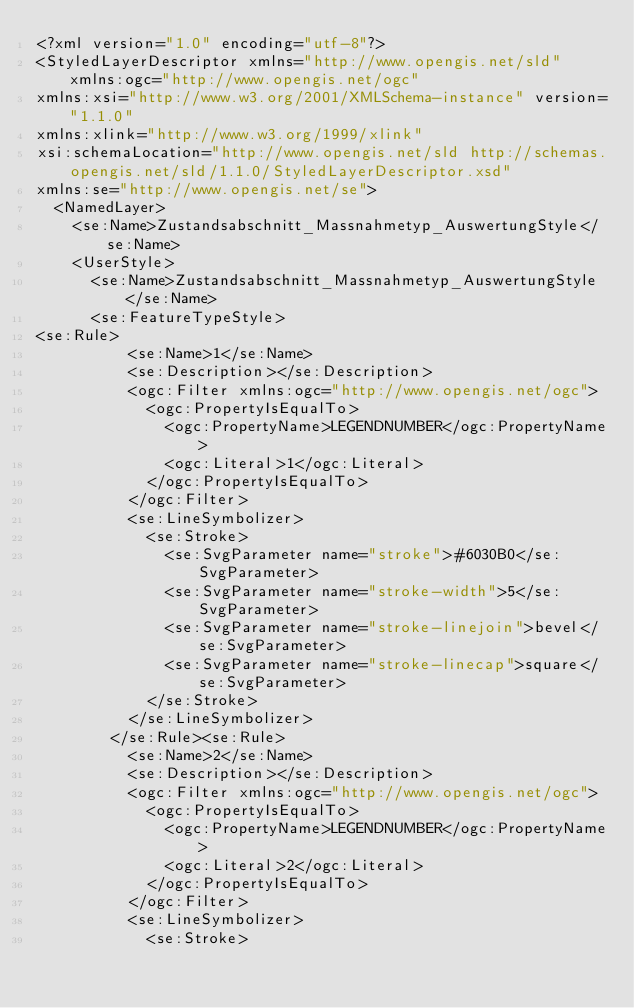<code> <loc_0><loc_0><loc_500><loc_500><_Scheme_><?xml version="1.0" encoding="utf-8"?>
<StyledLayerDescriptor xmlns="http://www.opengis.net/sld" xmlns:ogc="http://www.opengis.net/ogc"
xmlns:xsi="http://www.w3.org/2001/XMLSchema-instance" version="1.1.0"
xmlns:xlink="http://www.w3.org/1999/xlink" 
xsi:schemaLocation="http://www.opengis.net/sld http://schemas.opengis.net/sld/1.1.0/StyledLayerDescriptor.xsd"
xmlns:se="http://www.opengis.net/se">
  <NamedLayer>
    <se:Name>Zustandsabschnitt_Massnahmetyp_AuswertungStyle</se:Name>
    <UserStyle>
      <se:Name>Zustandsabschnitt_Massnahmetyp_AuswertungStyle</se:Name>
      <se:FeatureTypeStyle>
<se:Rule>
          <se:Name>1</se:Name>
          <se:Description></se:Description>
          <ogc:Filter xmlns:ogc="http://www.opengis.net/ogc">
            <ogc:PropertyIsEqualTo>
              <ogc:PropertyName>LEGENDNUMBER</ogc:PropertyName>
              <ogc:Literal>1</ogc:Literal>
            </ogc:PropertyIsEqualTo>
          </ogc:Filter>
          <se:LineSymbolizer>
            <se:Stroke>
              <se:SvgParameter name="stroke">#6030B0</se:SvgParameter>
              <se:SvgParameter name="stroke-width">5</se:SvgParameter>
              <se:SvgParameter name="stroke-linejoin">bevel</se:SvgParameter>
              <se:SvgParameter name="stroke-linecap">square</se:SvgParameter>
            </se:Stroke>
          </se:LineSymbolizer>
        </se:Rule><se:Rule>
          <se:Name>2</se:Name>
          <se:Description></se:Description>
          <ogc:Filter xmlns:ogc="http://www.opengis.net/ogc">
            <ogc:PropertyIsEqualTo>
              <ogc:PropertyName>LEGENDNUMBER</ogc:PropertyName>
              <ogc:Literal>2</ogc:Literal>
            </ogc:PropertyIsEqualTo>
          </ogc:Filter>
          <se:LineSymbolizer>
            <se:Stroke></code> 